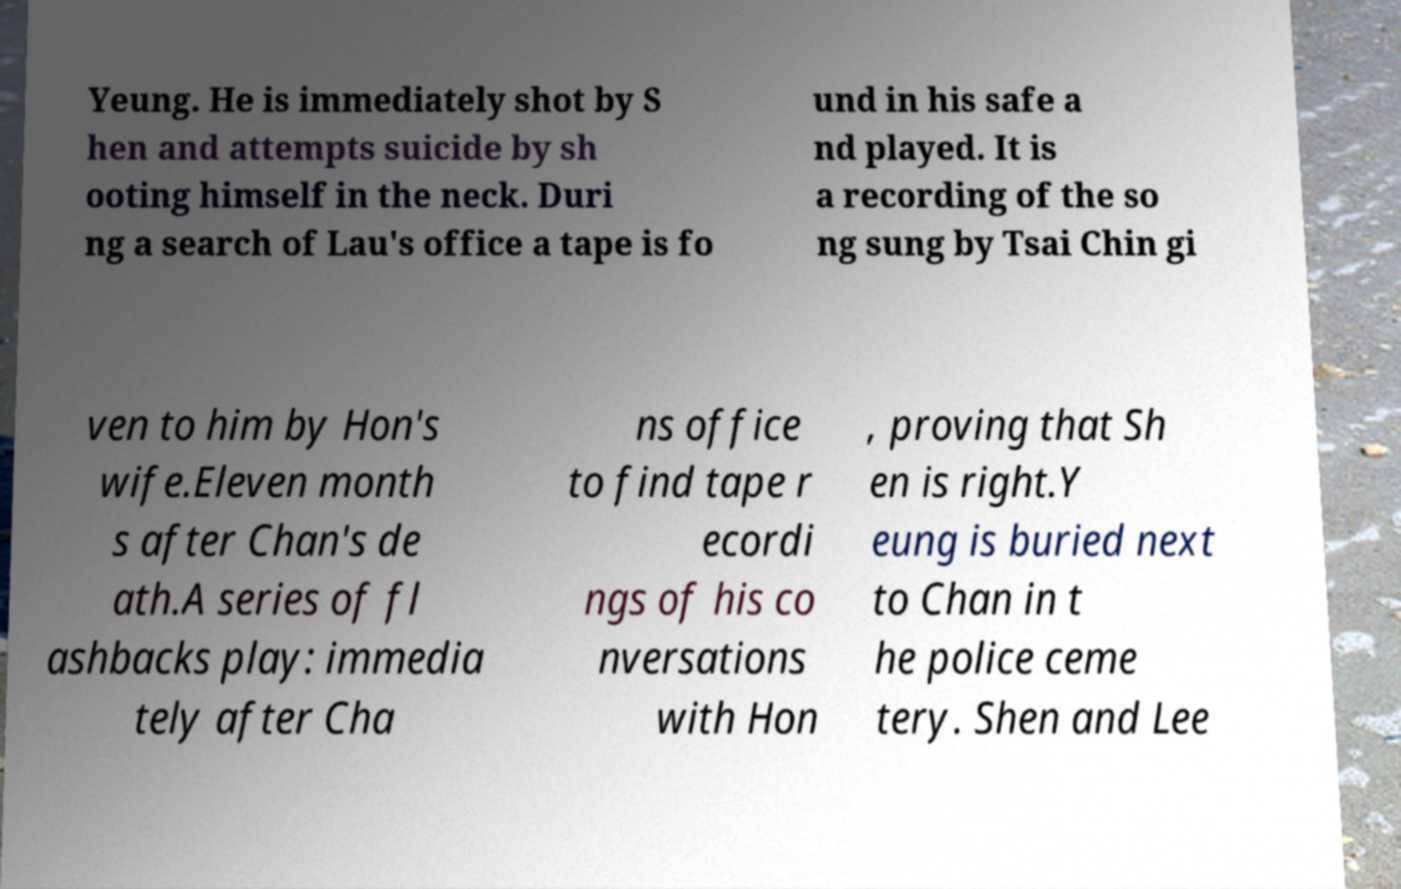Could you extract and type out the text from this image? Yeung. He is immediately shot by S hen and attempts suicide by sh ooting himself in the neck. Duri ng a search of Lau's office a tape is fo und in his safe a nd played. It is a recording of the so ng sung by Tsai Chin gi ven to him by Hon's wife.Eleven month s after Chan's de ath.A series of fl ashbacks play: immedia tely after Cha ns office to find tape r ecordi ngs of his co nversations with Hon , proving that Sh en is right.Y eung is buried next to Chan in t he police ceme tery. Shen and Lee 